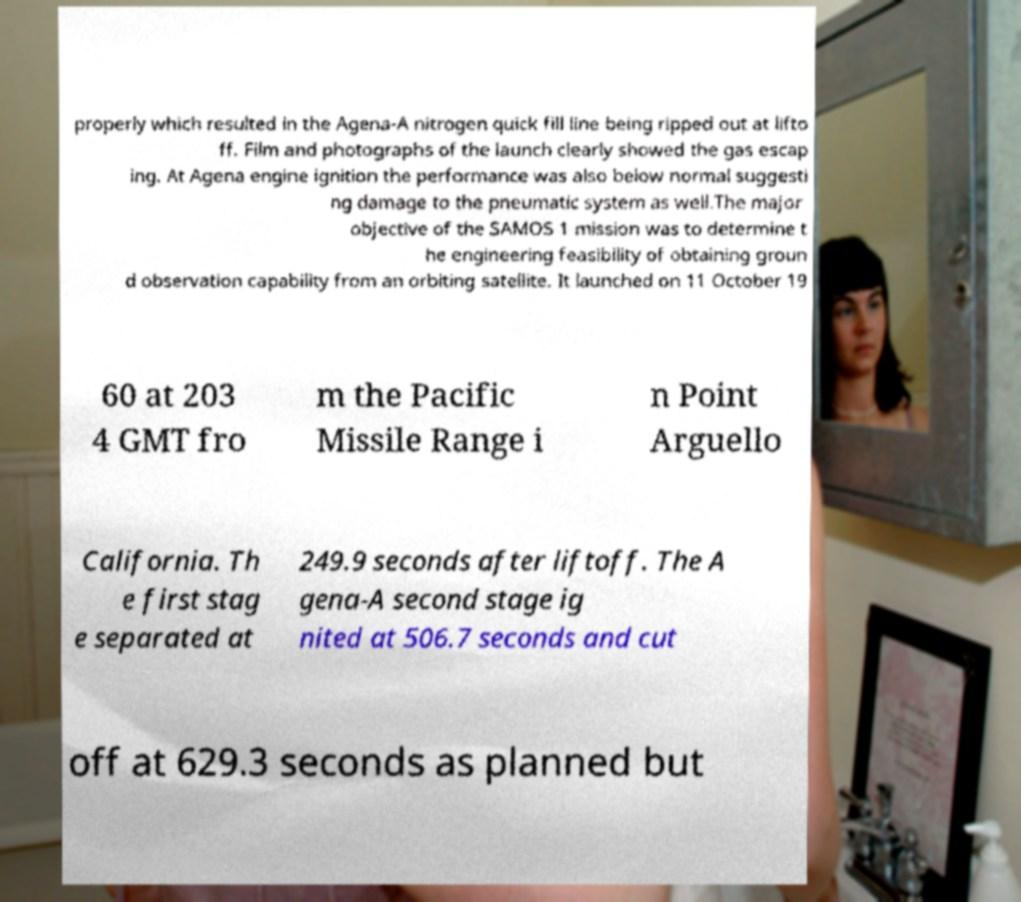Please identify and transcribe the text found in this image. properly which resulted in the Agena-A nitrogen quick fill line being ripped out at lifto ff. Film and photographs of the launch clearly showed the gas escap ing. At Agena engine ignition the performance was also below normal suggesti ng damage to the pneumatic system as well.The major objective of the SAMOS 1 mission was to determine t he engineering feasibility of obtaining groun d observation capability from an orbiting satellite. It launched on 11 October 19 60 at 203 4 GMT fro m the Pacific Missile Range i n Point Arguello California. Th e first stag e separated at 249.9 seconds after liftoff. The A gena-A second stage ig nited at 506.7 seconds and cut off at 629.3 seconds as planned but 